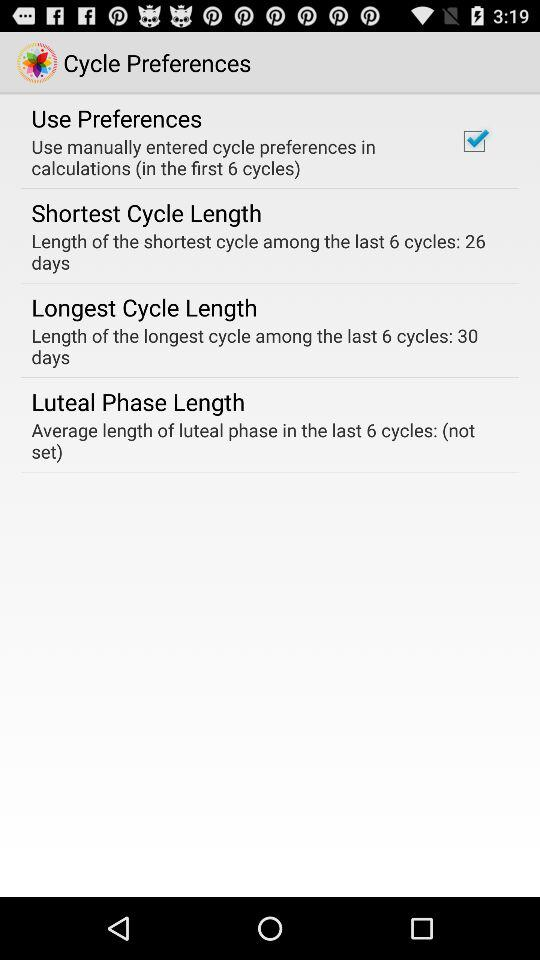What is the status of the "Use Preferences"? The status is "on". 